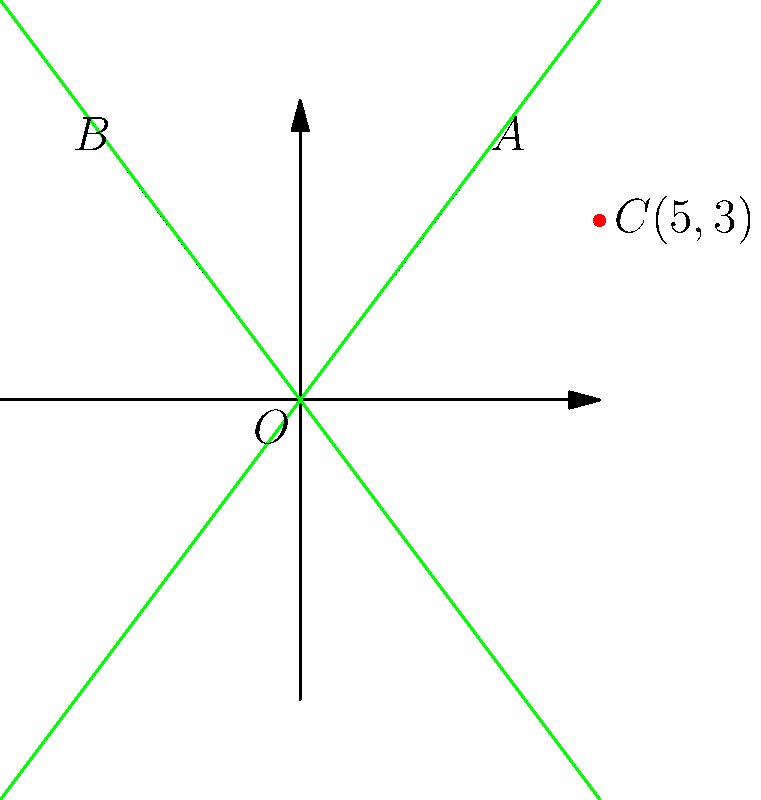As a brilliant scientist challenging conventional wisdom, you've encountered a hyperbola with asymptotes passing through points $A(3,4)$ and $B(-3,4)$, and a point $C(5,3)$ on the curve. Determine the eccentricity of this hyperbola to showcase your analytical prowess. Let's approach this step-by-step:

1) The equation of a hyperbola with center at the origin is $\frac{x^2}{a^2} - \frac{y^2}{b^2} = 1$, where $a$ and $b$ are the distances from the center to the vertices and co-vertices respectively.

2) The asymptotes of this hyperbola are given by the equations $y = \pm \frac{b}{a}x$.

3) From the given asymptotes passing through $A(3,4)$ and $B(-3,4)$, we can deduce that $\frac{b}{a} = \frac{4}{3}$.

4) The general equation of the asymptotes is $y^2 = (\frac{b}{a})^2 x^2$, or $y^2 = (\frac{4}{3})^2 x^2 = \frac{16}{9} x^2$.

5) The point $C(5,3)$ lies on the hyperbola. Substituting this into the hyperbola equation:

   $\frac{5^2}{a^2} - \frac{3^2}{b^2} = 1$

6) Using the relation $\frac{b}{a} = \frac{4}{3}$, we can express $b^2$ in terms of $a^2$:

   $b^2 = (\frac{4}{3})^2 a^2 = \frac{16}{9} a^2$

7) Substituting this into the equation from step 5:

   $\frac{25}{a^2} - \frac{9}{\frac{16}{9} a^2} = 1$

8) Simplifying:

   $\frac{25}{a^2} - \frac{81}{16a^2} = 1$
   $\frac{400}{16a^2} - \frac{81}{16a^2} = 1$
   $\frac{319}{16a^2} = 1$
   $a^2 = \frac{319}{16}$

9) The eccentricity $e$ of a hyperbola is given by $e = \sqrt{1 + \frac{b^2}{a^2}}$

10) Substituting the values we found:

    $e = \sqrt{1 + (\frac{4}{3})^2} = \sqrt{1 + \frac{16}{9}} = \sqrt{\frac{25}{9}} = \frac{5}{3}$

Thus, we have determined the eccentricity of the hyperbola.
Answer: $\frac{5}{3}$ 